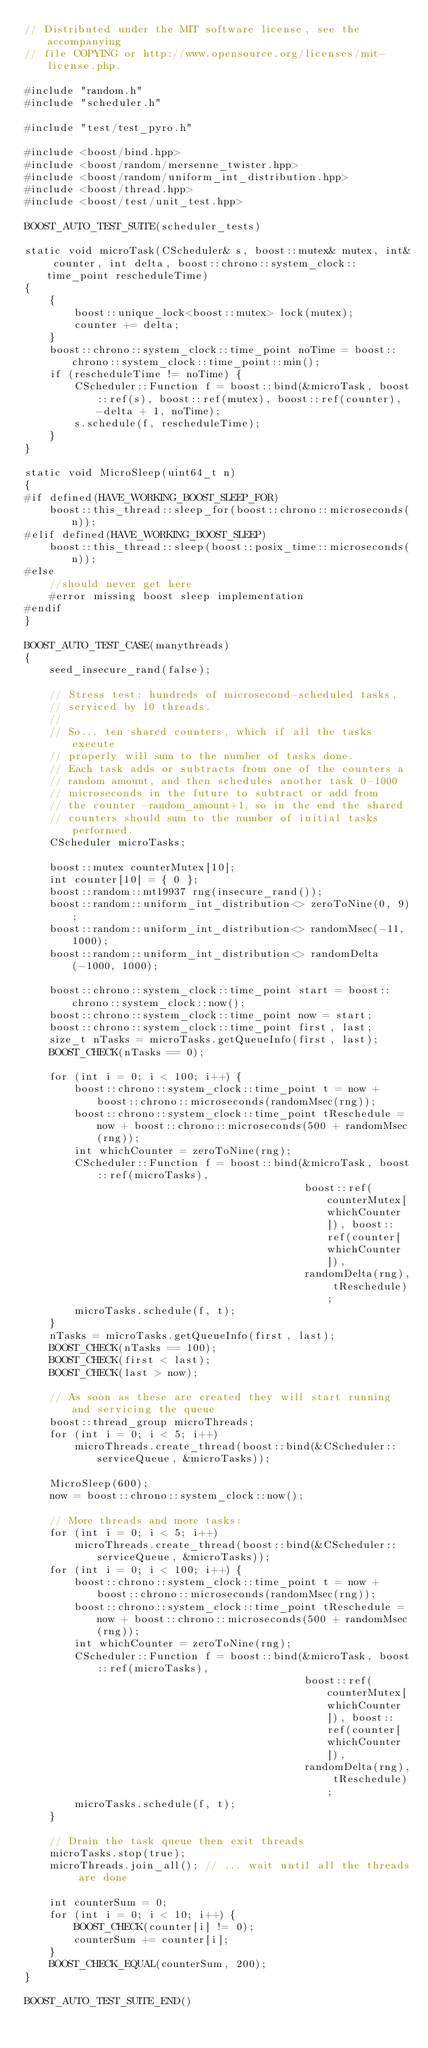<code> <loc_0><loc_0><loc_500><loc_500><_C++_>// Distributed under the MIT software license, see the accompanying
// file COPYING or http://www.opensource.org/licenses/mit-license.php.

#include "random.h"
#include "scheduler.h"

#include "test/test_pyro.h"

#include <boost/bind.hpp>
#include <boost/random/mersenne_twister.hpp>
#include <boost/random/uniform_int_distribution.hpp>
#include <boost/thread.hpp>
#include <boost/test/unit_test.hpp>

BOOST_AUTO_TEST_SUITE(scheduler_tests)

static void microTask(CScheduler& s, boost::mutex& mutex, int& counter, int delta, boost::chrono::system_clock::time_point rescheduleTime)
{
    {
        boost::unique_lock<boost::mutex> lock(mutex);
        counter += delta;
    }
    boost::chrono::system_clock::time_point noTime = boost::chrono::system_clock::time_point::min();
    if (rescheduleTime != noTime) {
        CScheduler::Function f = boost::bind(&microTask, boost::ref(s), boost::ref(mutex), boost::ref(counter), -delta + 1, noTime);
        s.schedule(f, rescheduleTime);
    }
}

static void MicroSleep(uint64_t n)
{
#if defined(HAVE_WORKING_BOOST_SLEEP_FOR)
    boost::this_thread::sleep_for(boost::chrono::microseconds(n));
#elif defined(HAVE_WORKING_BOOST_SLEEP)
    boost::this_thread::sleep(boost::posix_time::microseconds(n));
#else
    //should never get here
    #error missing boost sleep implementation
#endif
}

BOOST_AUTO_TEST_CASE(manythreads)
{
    seed_insecure_rand(false);

    // Stress test: hundreds of microsecond-scheduled tasks,
    // serviced by 10 threads.
    //
    // So... ten shared counters, which if all the tasks execute
    // properly will sum to the number of tasks done.
    // Each task adds or subtracts from one of the counters a
    // random amount, and then schedules another task 0-1000
    // microseconds in the future to subtract or add from
    // the counter -random_amount+1, so in the end the shared
    // counters should sum to the number of initial tasks performed.
    CScheduler microTasks;

    boost::mutex counterMutex[10];
    int counter[10] = { 0 };
    boost::random::mt19937 rng(insecure_rand());
    boost::random::uniform_int_distribution<> zeroToNine(0, 9);
    boost::random::uniform_int_distribution<> randomMsec(-11, 1000);
    boost::random::uniform_int_distribution<> randomDelta(-1000, 1000);

    boost::chrono::system_clock::time_point start = boost::chrono::system_clock::now();
    boost::chrono::system_clock::time_point now = start;
    boost::chrono::system_clock::time_point first, last;
    size_t nTasks = microTasks.getQueueInfo(first, last);
    BOOST_CHECK(nTasks == 0);

    for (int i = 0; i < 100; i++) {
        boost::chrono::system_clock::time_point t = now + boost::chrono::microseconds(randomMsec(rng));
        boost::chrono::system_clock::time_point tReschedule = now + boost::chrono::microseconds(500 + randomMsec(rng));
        int whichCounter = zeroToNine(rng);
        CScheduler::Function f = boost::bind(&microTask, boost::ref(microTasks),
                                             boost::ref(counterMutex[whichCounter]), boost::ref(counter[whichCounter]),
                                             randomDelta(rng), tReschedule);
        microTasks.schedule(f, t);
    }
    nTasks = microTasks.getQueueInfo(first, last);
    BOOST_CHECK(nTasks == 100);
    BOOST_CHECK(first < last);
    BOOST_CHECK(last > now);

    // As soon as these are created they will start running and servicing the queue
    boost::thread_group microThreads;
    for (int i = 0; i < 5; i++)
        microThreads.create_thread(boost::bind(&CScheduler::serviceQueue, &microTasks));

    MicroSleep(600);
    now = boost::chrono::system_clock::now();

    // More threads and more tasks:
    for (int i = 0; i < 5; i++)
        microThreads.create_thread(boost::bind(&CScheduler::serviceQueue, &microTasks));
    for (int i = 0; i < 100; i++) {
        boost::chrono::system_clock::time_point t = now + boost::chrono::microseconds(randomMsec(rng));
        boost::chrono::system_clock::time_point tReschedule = now + boost::chrono::microseconds(500 + randomMsec(rng));
        int whichCounter = zeroToNine(rng);
        CScheduler::Function f = boost::bind(&microTask, boost::ref(microTasks),
                                             boost::ref(counterMutex[whichCounter]), boost::ref(counter[whichCounter]),
                                             randomDelta(rng), tReschedule);
        microTasks.schedule(f, t);
    }

    // Drain the task queue then exit threads
    microTasks.stop(true);
    microThreads.join_all(); // ... wait until all the threads are done

    int counterSum = 0;
    for (int i = 0; i < 10; i++) {
        BOOST_CHECK(counter[i] != 0);
        counterSum += counter[i];
    }
    BOOST_CHECK_EQUAL(counterSum, 200);
}

BOOST_AUTO_TEST_SUITE_END()
</code> 